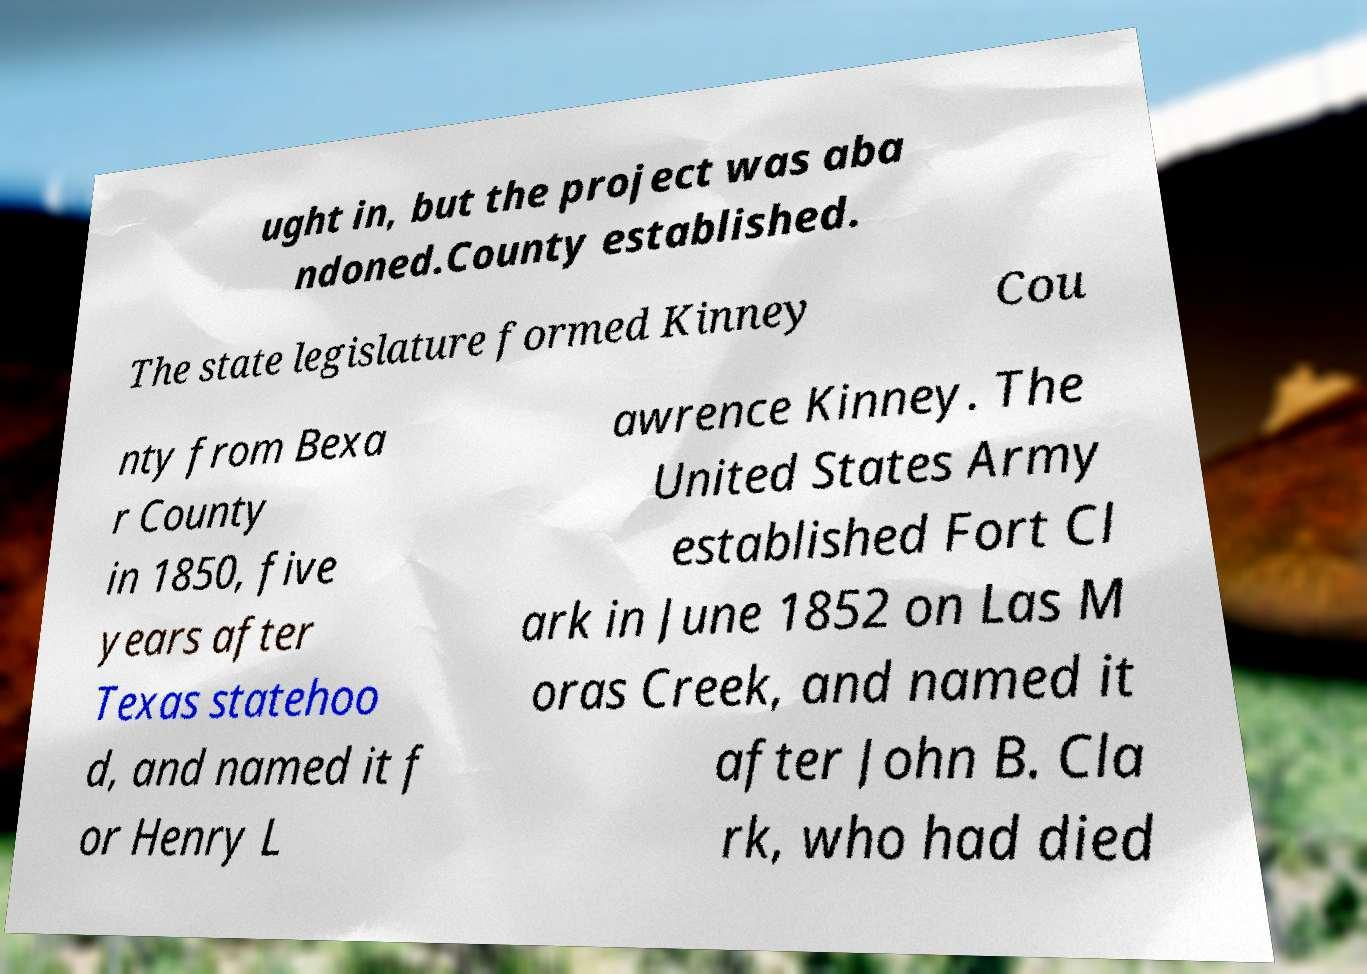What messages or text are displayed in this image? I need them in a readable, typed format. ught in, but the project was aba ndoned.County established. The state legislature formed Kinney Cou nty from Bexa r County in 1850, five years after Texas statehoo d, and named it f or Henry L awrence Kinney. The United States Army established Fort Cl ark in June 1852 on Las M oras Creek, and named it after John B. Cla rk, who had died 